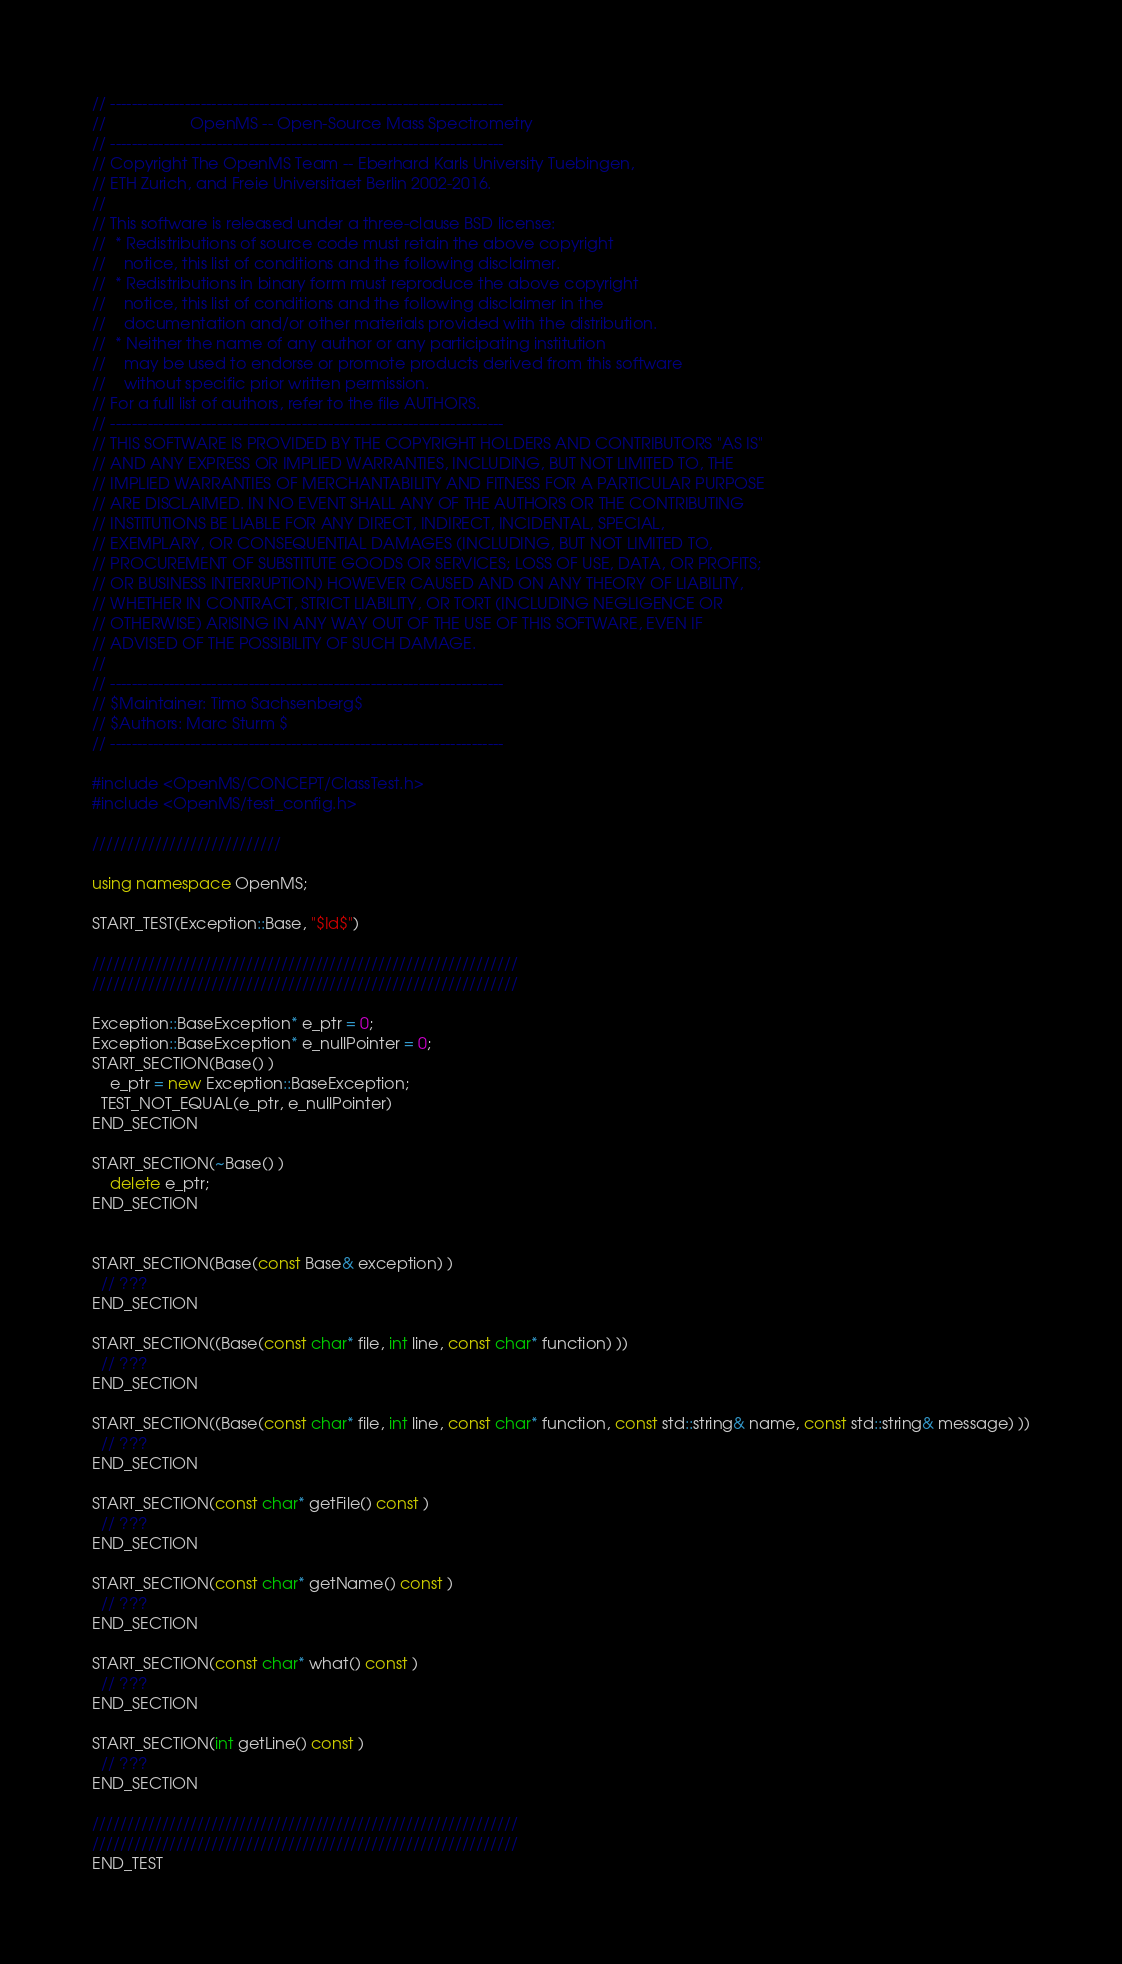Convert code to text. <code><loc_0><loc_0><loc_500><loc_500><_C++_>// --------------------------------------------------------------------------
//                   OpenMS -- Open-Source Mass Spectrometry               
// --------------------------------------------------------------------------
// Copyright The OpenMS Team -- Eberhard Karls University Tuebingen,
// ETH Zurich, and Freie Universitaet Berlin 2002-2016.
// 
// This software is released under a three-clause BSD license:
//  * Redistributions of source code must retain the above copyright
//    notice, this list of conditions and the following disclaimer.
//  * Redistributions in binary form must reproduce the above copyright
//    notice, this list of conditions and the following disclaimer in the
//    documentation and/or other materials provided with the distribution.
//  * Neither the name of any author or any participating institution 
//    may be used to endorse or promote products derived from this software 
//    without specific prior written permission.
// For a full list of authors, refer to the file AUTHORS. 
// --------------------------------------------------------------------------
// THIS SOFTWARE IS PROVIDED BY THE COPYRIGHT HOLDERS AND CONTRIBUTORS "AS IS"
// AND ANY EXPRESS OR IMPLIED WARRANTIES, INCLUDING, BUT NOT LIMITED TO, THE
// IMPLIED WARRANTIES OF MERCHANTABILITY AND FITNESS FOR A PARTICULAR PURPOSE
// ARE DISCLAIMED. IN NO EVENT SHALL ANY OF THE AUTHORS OR THE CONTRIBUTING 
// INSTITUTIONS BE LIABLE FOR ANY DIRECT, INDIRECT, INCIDENTAL, SPECIAL, 
// EXEMPLARY, OR CONSEQUENTIAL DAMAGES (INCLUDING, BUT NOT LIMITED TO, 
// PROCUREMENT OF SUBSTITUTE GOODS OR SERVICES; LOSS OF USE, DATA, OR PROFITS; 
// OR BUSINESS INTERRUPTION) HOWEVER CAUSED AND ON ANY THEORY OF LIABILITY, 
// WHETHER IN CONTRACT, STRICT LIABILITY, OR TORT (INCLUDING NEGLIGENCE OR 
// OTHERWISE) ARISING IN ANY WAY OUT OF THE USE OF THIS SOFTWARE, EVEN IF 
// ADVISED OF THE POSSIBILITY OF SUCH DAMAGE.
// 
// --------------------------------------------------------------------------
// $Maintainer: Timo Sachsenberg$
// $Authors: Marc Sturm $
// --------------------------------------------------------------------------

#include <OpenMS/CONCEPT/ClassTest.h>
#include <OpenMS/test_config.h>

///////////////////////////

using namespace OpenMS;

START_TEST(Exception::Base, "$Id$")

/////////////////////////////////////////////////////////////
/////////////////////////////////////////////////////////////

Exception::BaseException* e_ptr = 0;
Exception::BaseException* e_nullPointer = 0;
START_SECTION(Base() )
	e_ptr = new Exception::BaseException;
  TEST_NOT_EQUAL(e_ptr, e_nullPointer)
END_SECTION

START_SECTION(~Base() )
	delete e_ptr;
END_SECTION


START_SECTION(Base(const Base& exception) )
  // ???
END_SECTION

START_SECTION((Base(const char* file, int line, const char* function) ))
  // ???
END_SECTION

START_SECTION((Base(const char* file, int line, const char* function, const std::string& name, const std::string& message) ))
  // ???
END_SECTION

START_SECTION(const char* getFile() const )
  // ???
END_SECTION

START_SECTION(const char* getName() const )
  // ???
END_SECTION

START_SECTION(const char* what() const )
  // ???
END_SECTION

START_SECTION(int getLine() const )
  // ???
END_SECTION

/////////////////////////////////////////////////////////////
/////////////////////////////////////////////////////////////
END_TEST
</code> 